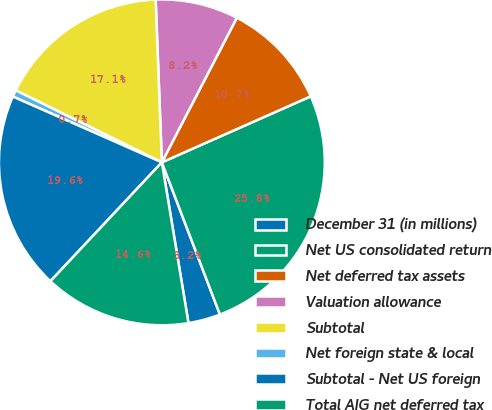Convert chart. <chart><loc_0><loc_0><loc_500><loc_500><pie_chart><fcel>December 31 (in millions)<fcel>Net US consolidated return<fcel>Net deferred tax assets<fcel>Valuation allowance<fcel>Subtotal<fcel>Net foreign state & local<fcel>Subtotal - Net US foreign<fcel>Total AIG net deferred tax<nl><fcel>3.19%<fcel>25.84%<fcel>10.74%<fcel>8.22%<fcel>17.11%<fcel>0.67%<fcel>19.63%<fcel>14.6%<nl></chart> 